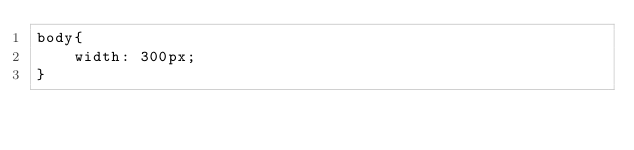Convert code to text. <code><loc_0><loc_0><loc_500><loc_500><_CSS_>body{
	width: 300px;
}</code> 